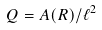Convert formula to latex. <formula><loc_0><loc_0><loc_500><loc_500>Q = A ( R ) / \ell ^ { 2 }</formula> 